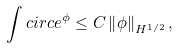Convert formula to latex. <formula><loc_0><loc_0><loc_500><loc_500>\int c i r c e ^ { \phi } \leq C \left \| \phi \right \| _ { H ^ { 1 / 2 } } ,</formula> 